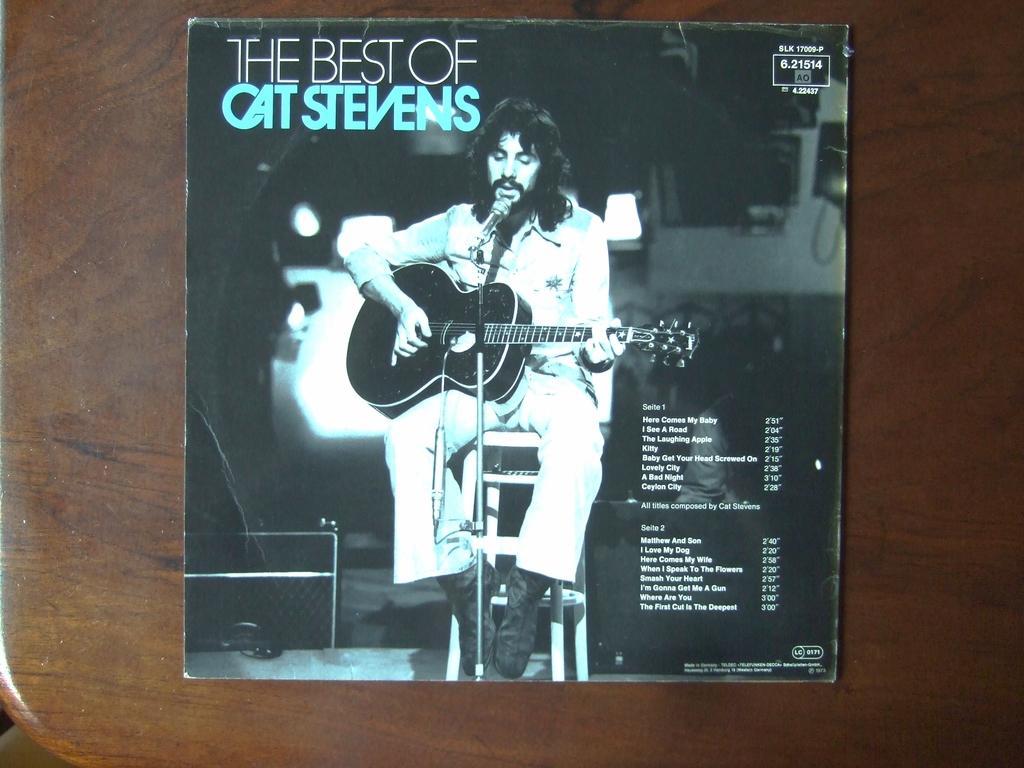Please provide a concise description of this image. In this image I can see a poster in which I can see a person holding a guitar. I can also see some text written on it. In the background, I can see the table. 